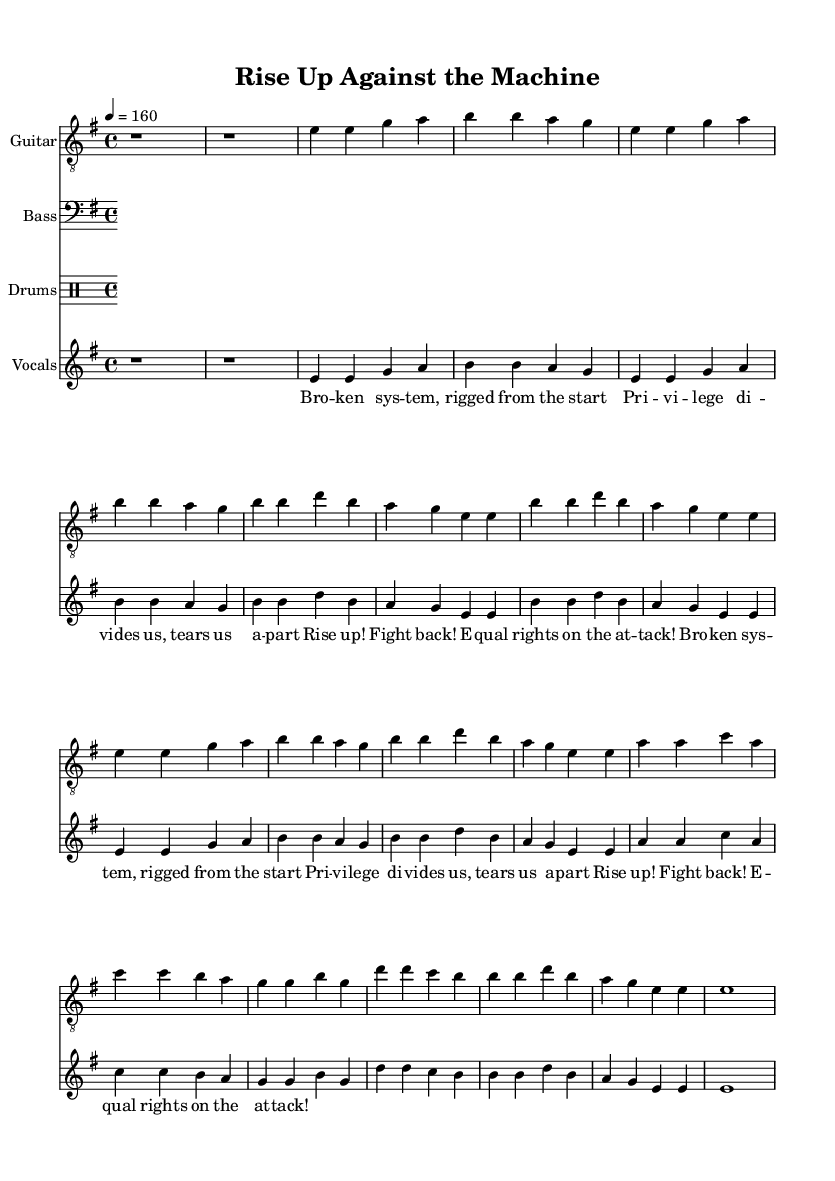What is the key signature of this music? The key signature is indicated at the beginning of the score. It shows one sharp sign, which corresponds to E minor.
Answer: E minor What is the time signature of this music? The time signature is found at the beginning of the score, indicating how many beats are in each measure. Here, it shows 4 over 4.
Answer: 4/4 What is the tempo marking for this piece? The tempo marking is stated above the staff, which specifies the speed of the music. It indicates a tempo of 160 beats per minute.
Answer: 160 How many verses are in the song? By examining the lyrics section, we find two instances of the verse section clearly marked as Verse 1 and Verse 2.
Answer: 2 What musical style does this piece represent? The characteristics of the music, including the structure of the lyrics and the vigorous rhythm, indicate it is a punk anthem, focusing on social and political themes.
Answer: Punk What is the primary message of the chorus? The chorus lyrics contain a call to action, emphasizing fighting back against inequalities and injustices, reflecting themes common in protest punk.
Answer: Rise up! Fight back! 